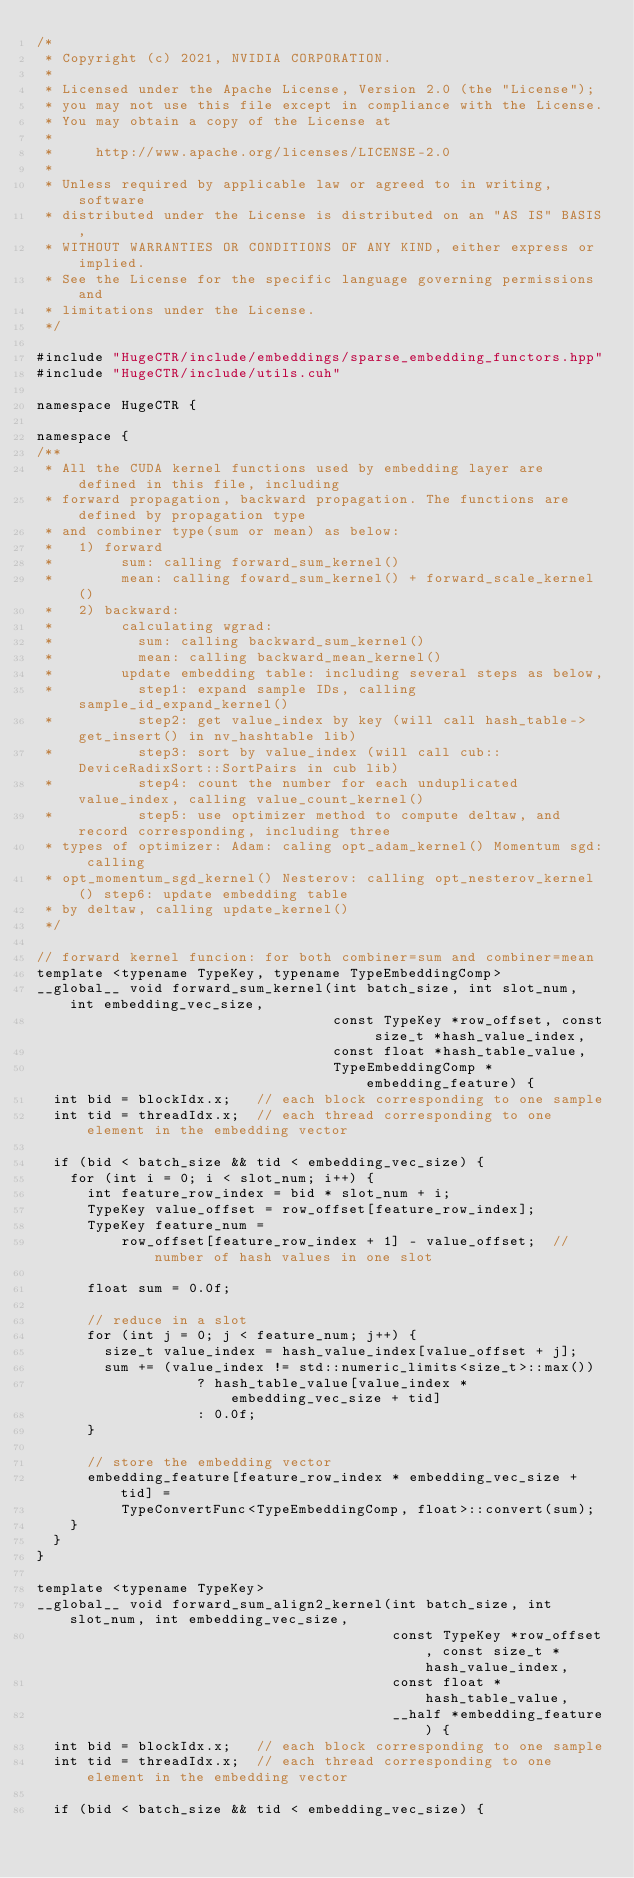Convert code to text. <code><loc_0><loc_0><loc_500><loc_500><_Cuda_>/*
 * Copyright (c) 2021, NVIDIA CORPORATION.
 *
 * Licensed under the Apache License, Version 2.0 (the "License");
 * you may not use this file except in compliance with the License.
 * You may obtain a copy of the License at
 *
 *     http://www.apache.org/licenses/LICENSE-2.0
 *
 * Unless required by applicable law or agreed to in writing, software
 * distributed under the License is distributed on an "AS IS" BASIS,
 * WITHOUT WARRANTIES OR CONDITIONS OF ANY KIND, either express or implied.
 * See the License for the specific language governing permissions and
 * limitations under the License.
 */

#include "HugeCTR/include/embeddings/sparse_embedding_functors.hpp"
#include "HugeCTR/include/utils.cuh"

namespace HugeCTR {

namespace {
/**
 * All the CUDA kernel functions used by embedding layer are defined in this file, including
 * forward propagation, backward propagation. The functions are defined by propagation type
 * and combiner type(sum or mean) as below:
 *   1) forward
 *        sum: calling forward_sum_kernel()
 *        mean: calling foward_sum_kernel() + forward_scale_kernel()
 *   2) backward:
 *        calculating wgrad:
 *          sum: calling backward_sum_kernel()
 *          mean: calling backward_mean_kernel()
 *        update embedding table: including several steps as below,
 *          step1: expand sample IDs, calling sample_id_expand_kernel()
 *          step2: get value_index by key (will call hash_table->get_insert() in nv_hashtable lib)
 *          step3: sort by value_index (will call cub::DeviceRadixSort::SortPairs in cub lib)
 *          step4: count the number for each unduplicated value_index, calling value_count_kernel()
 *          step5: use optimizer method to compute deltaw, and record corresponding, including three
 * types of optimizer: Adam: caling opt_adam_kernel() Momentum sgd: calling
 * opt_momentum_sgd_kernel() Nesterov: calling opt_nesterov_kernel() step6: update embedding table
 * by deltaw, calling update_kernel()
 */

// forward kernel funcion: for both combiner=sum and combiner=mean
template <typename TypeKey, typename TypeEmbeddingComp>
__global__ void forward_sum_kernel(int batch_size, int slot_num, int embedding_vec_size,
                                   const TypeKey *row_offset, const size_t *hash_value_index,
                                   const float *hash_table_value,
                                   TypeEmbeddingComp *embedding_feature) {
  int bid = blockIdx.x;   // each block corresponding to one sample
  int tid = threadIdx.x;  // each thread corresponding to one element in the embedding vector

  if (bid < batch_size && tid < embedding_vec_size) {
    for (int i = 0; i < slot_num; i++) {
      int feature_row_index = bid * slot_num + i;
      TypeKey value_offset = row_offset[feature_row_index];
      TypeKey feature_num =
          row_offset[feature_row_index + 1] - value_offset;  // number of hash values in one slot

      float sum = 0.0f;

      // reduce in a slot
      for (int j = 0; j < feature_num; j++) {
        size_t value_index = hash_value_index[value_offset + j];
        sum += (value_index != std::numeric_limits<size_t>::max())
                   ? hash_table_value[value_index * embedding_vec_size + tid]
                   : 0.0f;
      }

      // store the embedding vector
      embedding_feature[feature_row_index * embedding_vec_size + tid] =
          TypeConvertFunc<TypeEmbeddingComp, float>::convert(sum);
    }
  }
}

template <typename TypeKey>
__global__ void forward_sum_align2_kernel(int batch_size, int slot_num, int embedding_vec_size,
                                          const TypeKey *row_offset, const size_t *hash_value_index,
                                          const float *hash_table_value,
                                          __half *embedding_feature) {
  int bid = blockIdx.x;   // each block corresponding to one sample
  int tid = threadIdx.x;  // each thread corresponding to one element in the embedding vector

  if (bid < batch_size && tid < embedding_vec_size) {</code> 